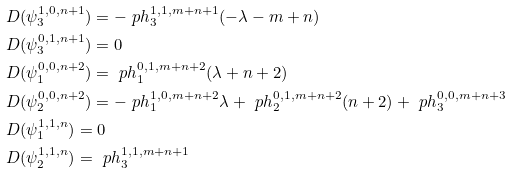Convert formula to latex. <formula><loc_0><loc_0><loc_500><loc_500>& D ( \psi ^ { 1 , 0 , n + 1 } _ { 3 } ) = - \ p h ^ { 1 , 1 , m + n + 1 } _ { 3 } ( - \lambda - m + n ) \\ & D ( \psi ^ { 0 , 1 , n + 1 } _ { 3 } ) = 0 \\ & D ( \psi ^ { 0 , 0 , n + 2 } _ { 1 } ) = \ p h ^ { 0 , 1 , m + n + 2 } _ { 1 } ( \lambda + n + 2 ) \\ & D ( \psi ^ { 0 , 0 , n + 2 } _ { 2 } ) = - \ p h ^ { 1 , 0 , m + n + 2 } _ { 1 } \lambda + \ p h ^ { 0 , 1 , m + n + 2 } _ { 2 } ( n + 2 ) + \ p h ^ { 0 , 0 , m + n + 3 } _ { 3 } \\ & D ( \psi ^ { 1 , 1 , n } _ { 1 } ) = 0 \\ & D ( \psi ^ { 1 , 1 , n } _ { 2 } ) = \ p h ^ { 1 , 1 , m + n + 1 } _ { 3 }</formula> 